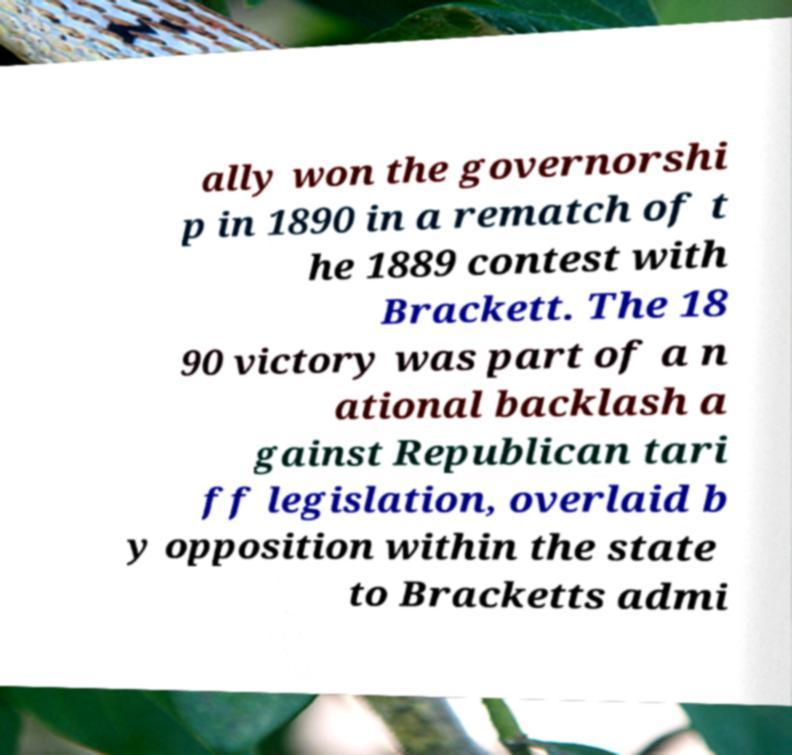There's text embedded in this image that I need extracted. Can you transcribe it verbatim? ally won the governorshi p in 1890 in a rematch of t he 1889 contest with Brackett. The 18 90 victory was part of a n ational backlash a gainst Republican tari ff legislation, overlaid b y opposition within the state to Bracketts admi 